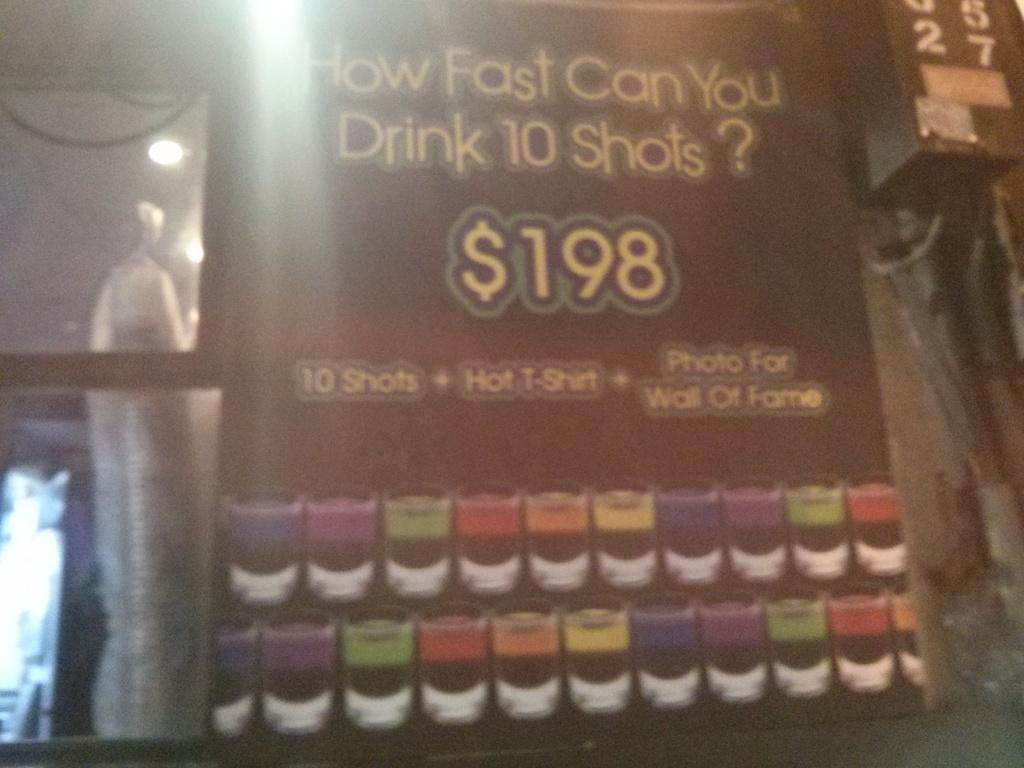<image>
Create a compact narrative representing the image presented. An advertisement asking how fast you can drinking 10 shots. 